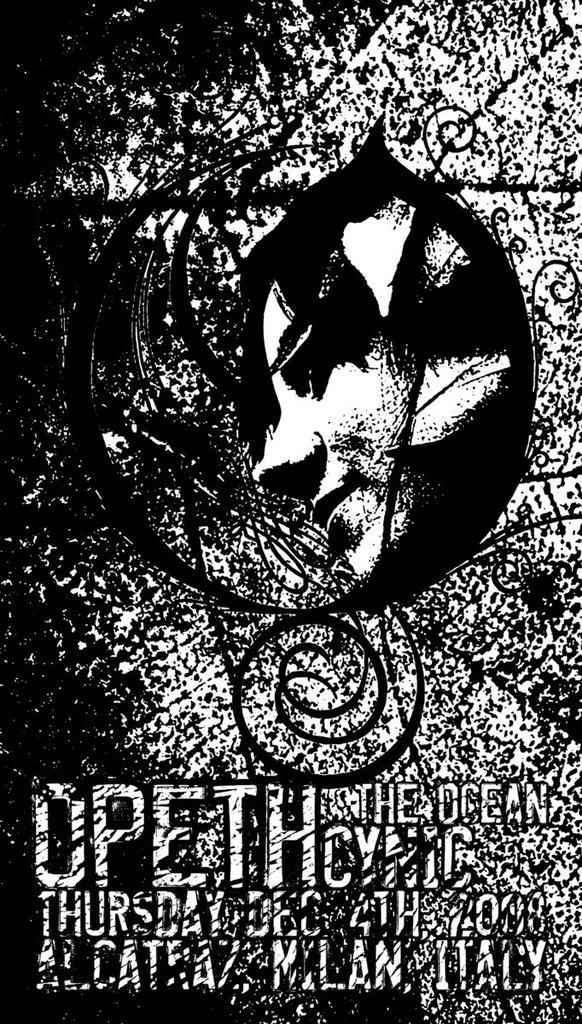What is the color scheme of the image? The image is black and white in color. What is the main subject of the image? There is a depiction of a person's face in the image. Are there any words or letters in the image? Yes, there is text written in the image. What type of coal is being mined by the dinosaurs in the image? There are no dinosaurs or coal present in the image; it features a black and white depiction of a person's face with text. 